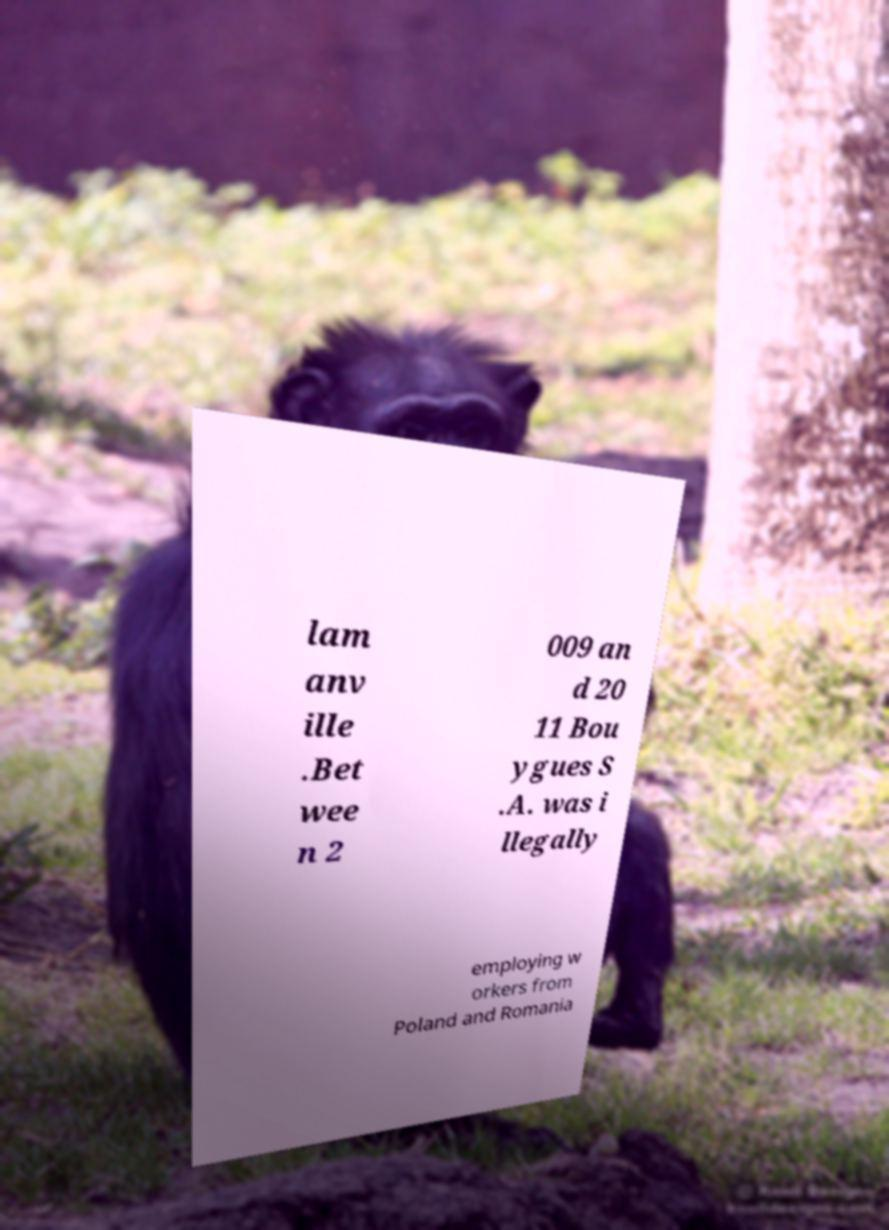I need the written content from this picture converted into text. Can you do that? lam anv ille .Bet wee n 2 009 an d 20 11 Bou ygues S .A. was i llegally employing w orkers from Poland and Romania 